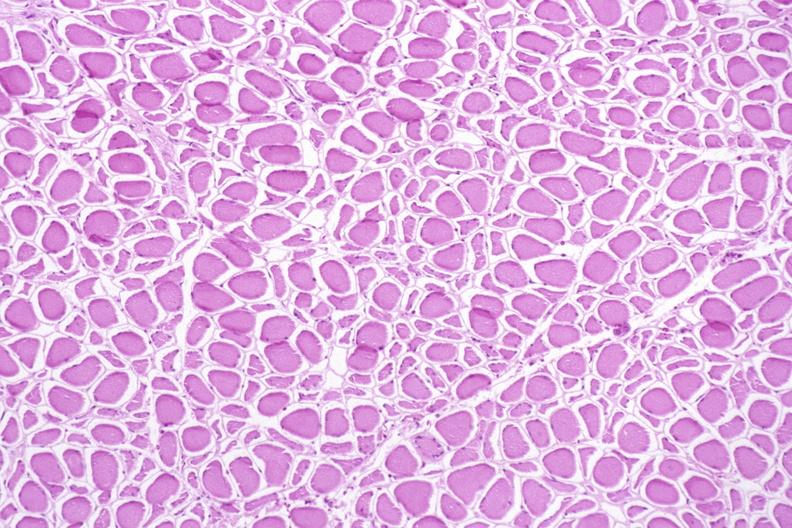what is present?
Answer the question using a single word or phrase. Musculoskeletal 